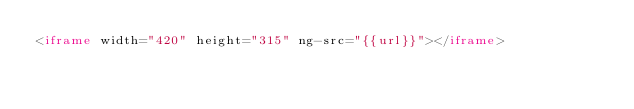Convert code to text. <code><loc_0><loc_0><loc_500><loc_500><_HTML_><iframe width="420" height="315" ng-src="{{url}}"></iframe></code> 